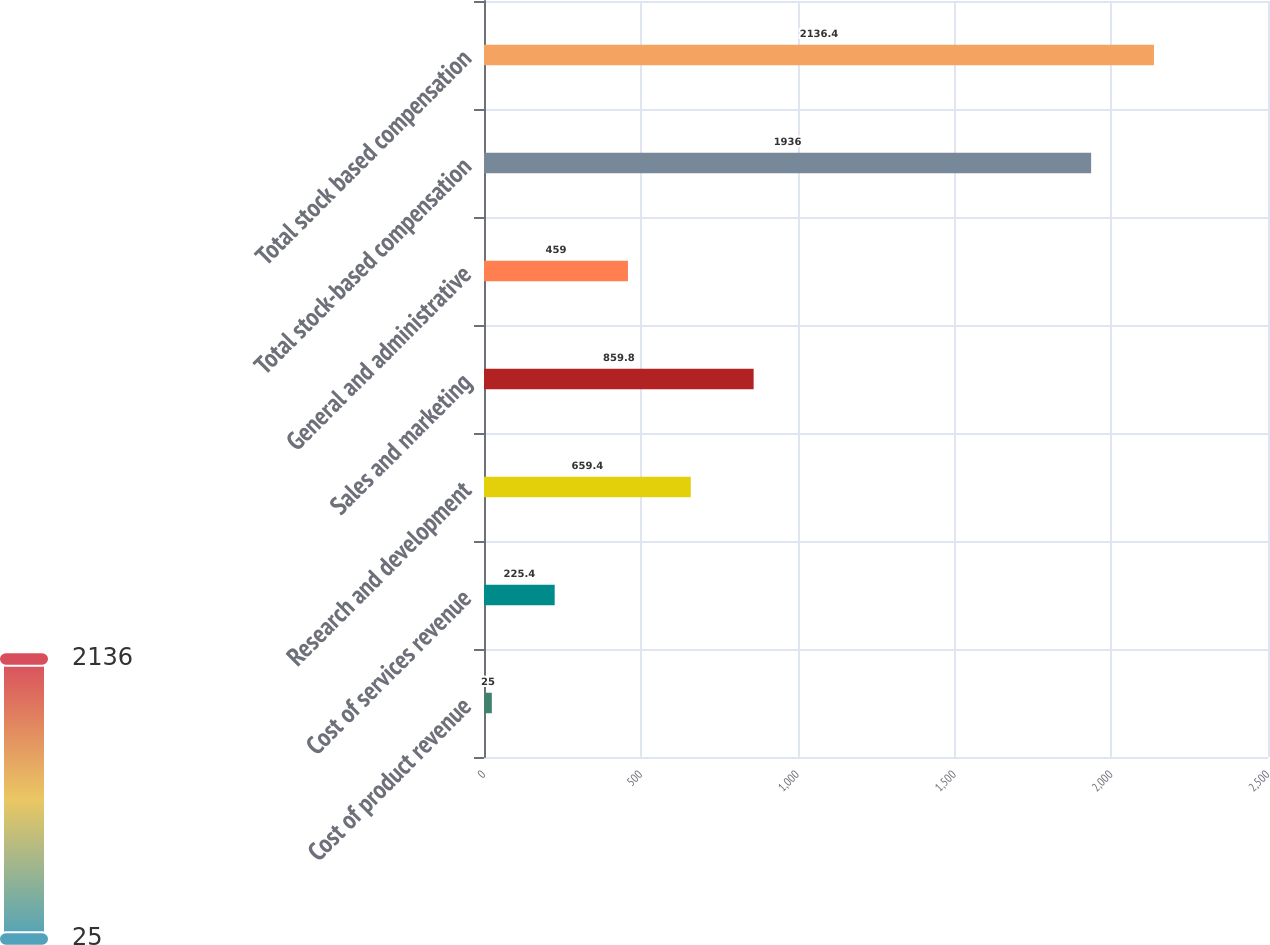Convert chart to OTSL. <chart><loc_0><loc_0><loc_500><loc_500><bar_chart><fcel>Cost of product revenue<fcel>Cost of services revenue<fcel>Research and development<fcel>Sales and marketing<fcel>General and administrative<fcel>Total stock-based compensation<fcel>Total stock based compensation<nl><fcel>25<fcel>225.4<fcel>659.4<fcel>859.8<fcel>459<fcel>1936<fcel>2136.4<nl></chart> 